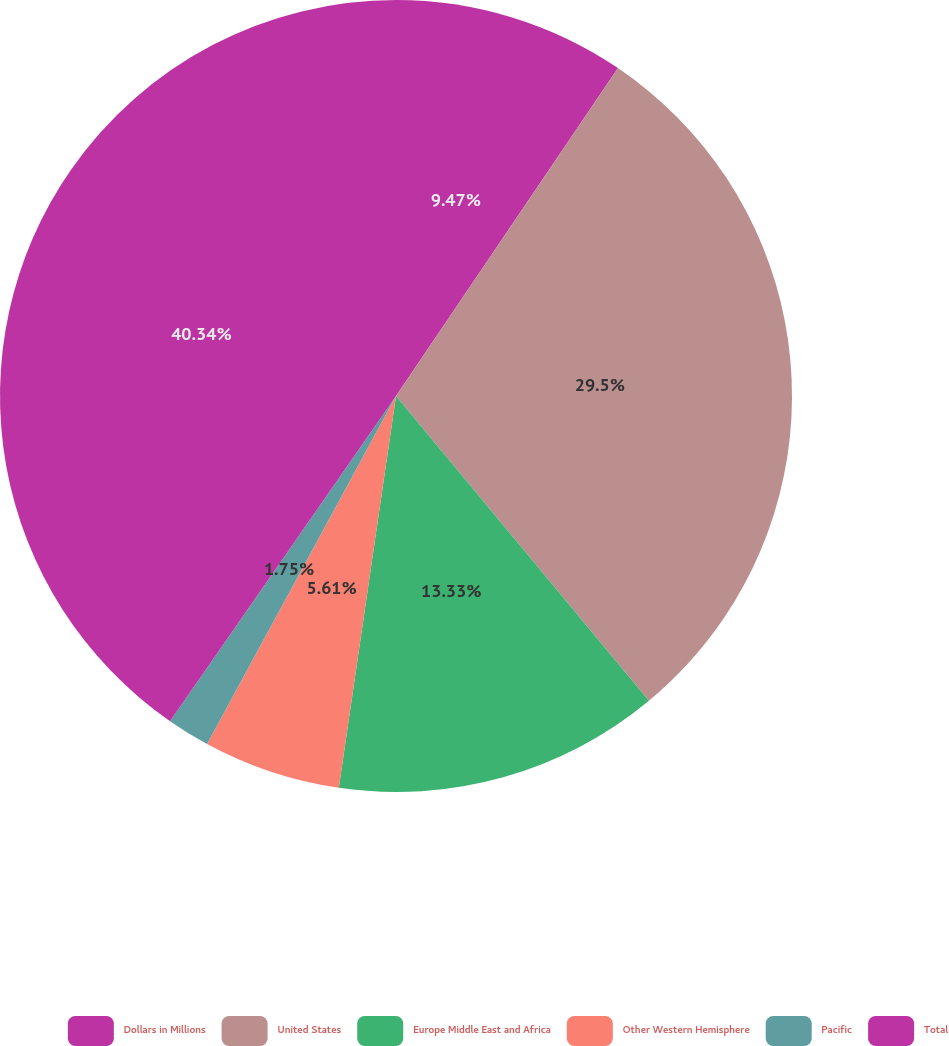Convert chart to OTSL. <chart><loc_0><loc_0><loc_500><loc_500><pie_chart><fcel>Dollars in Millions<fcel>United States<fcel>Europe Middle East and Africa<fcel>Other Western Hemisphere<fcel>Pacific<fcel>Total<nl><fcel>9.47%<fcel>29.5%<fcel>13.33%<fcel>5.61%<fcel>1.75%<fcel>40.33%<nl></chart> 